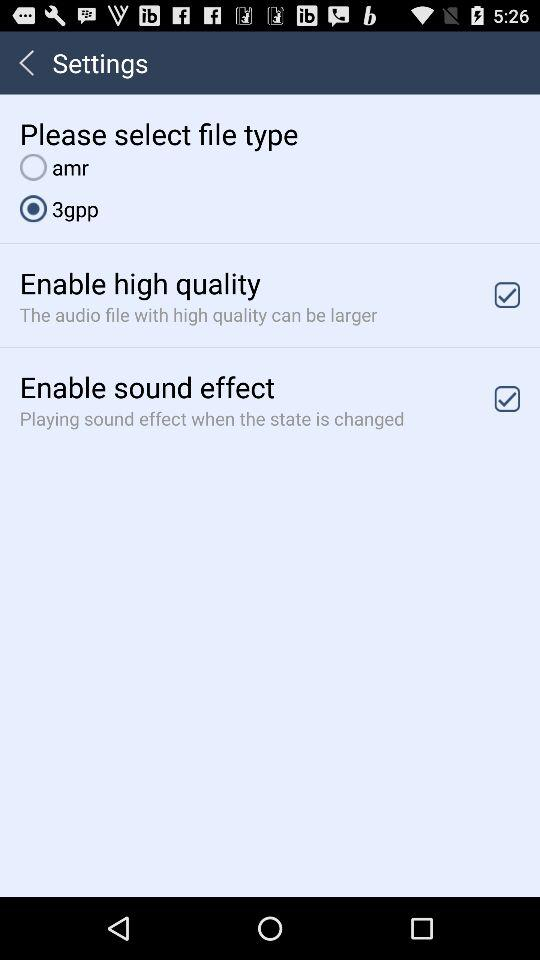Which option is selected for the file type? The selected option is "3gpp". 